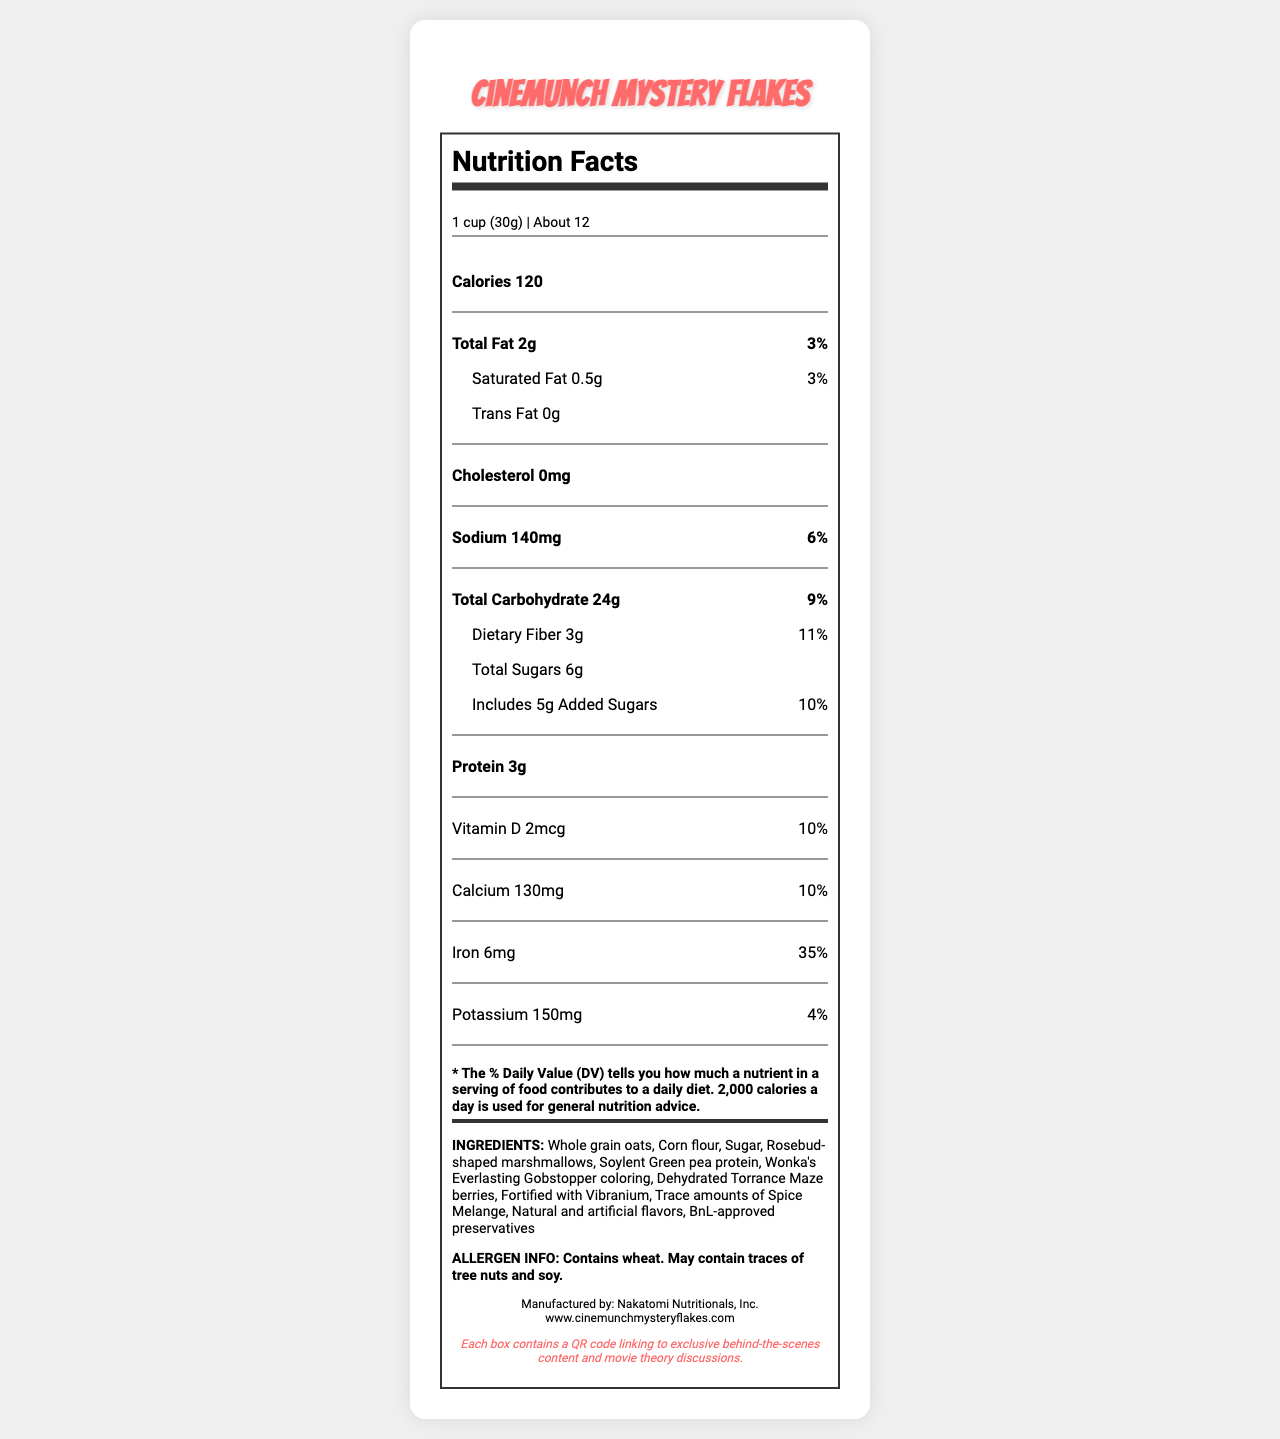what is the serving size? The serving size is explicitly mentioned at the top of the nutritional facts section.
Answer: 1 cup (30g) how many calories are there per serving? The number of calories per serving is stated under the main nutrition information.
Answer: 120 which ingredient is used to give a unique color to the cereal? The ingredient list includes "Wonka's Everlasting Gobstopper coloring," indicating this is used for coloring.
Answer: Wonka's Everlasting Gobstopper coloring what is the percentage daily value of iron? The daily value percentage for iron is shown next to its amount under the nutrient section.
Answer: 35% how much sodium is in one serving of the cereal? The sodium content is specified as 140mg in the nutrition information.
Answer: 140mg which of the following ingredients is not mentioned in the list? A. Whole grain oats B. Soy protein C. Rosebud-shaped marshmallows D. Vibranium The ingredient "Soy protein" is not listed, while the other options are present.
Answer: B how much added sugar does the cereal contain per serving? A. 3g B. 5g C. 6g D. 4g The document lists "5g" as the amount of added sugars per serving.
Answer: B does the cereal contain any tree nuts? The allergen information states that it may contain traces of tree nuts.
Answer: May contain describe the main idea of this document. The document focuses on describing the nutritional content, serving size, ingredients, and allergen information for the cereal, along with a special note about additional movie-related content.
Answer: The document provides the nutritional facts and ingredient information for CineMunch Mystery Flakes, a limited edition cereal that features unique ingredients inspired by movie references. It includes details about serving size, calories, nutrients, and special note about QR code linking to exclusive content. what is the website for more information about this product? The website for more information is mentioned at the bottom of the document.
Answer: www.cinemunchmysteryflakes.com is the cereal fortified with a special fictional element? The ingredient list includes "Fortified with Vibranium," which is a fictional element.
Answer: Yes can I find out the total revenue generated from this cereal based on the document? The document does not provide any information related to sales or revenue figures.
Answer: Cannot be determined how many servings are approximately contained in one package of the cereal? The document states that there are about 12 servings per container.
Answer: About 12 who is the manufacturer of this cereal? The manufacturer information is listed at the bottom of the document.
Answer: Nakatomi Nutritionals, Inc. 